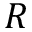<formula> <loc_0><loc_0><loc_500><loc_500>R</formula> 